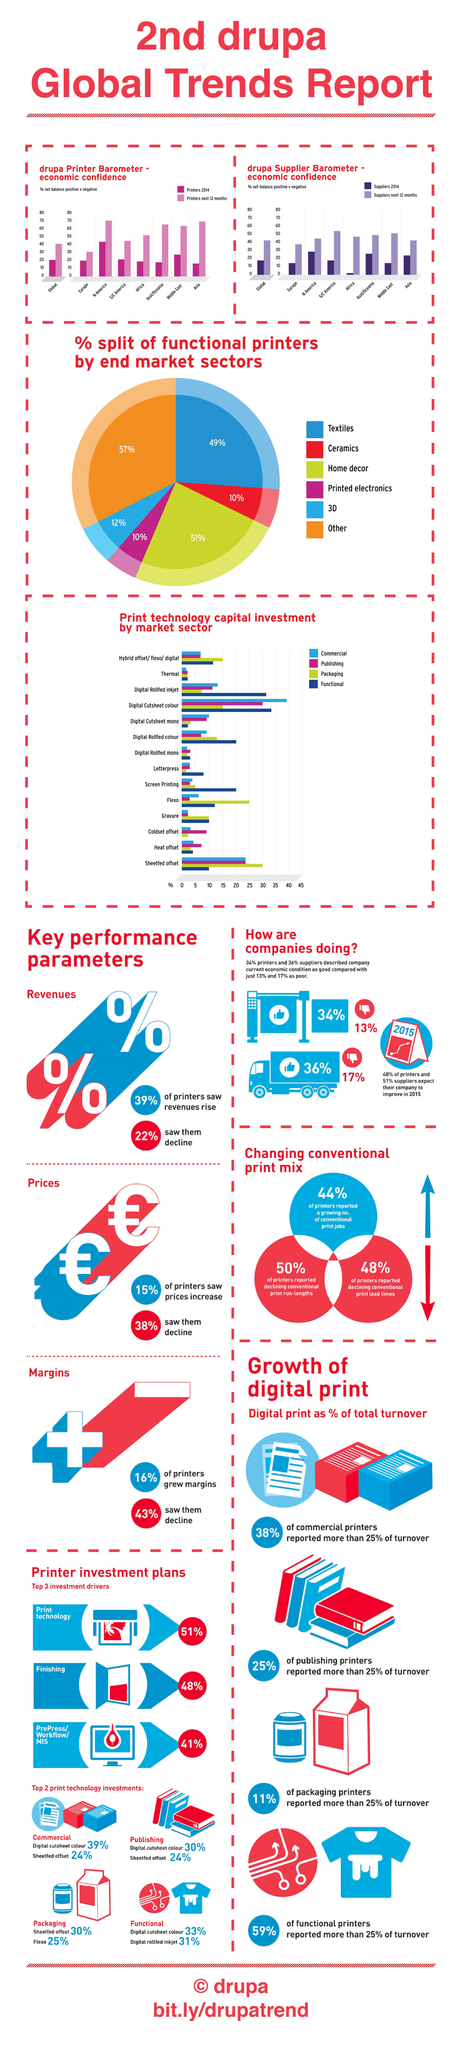Which are the two print technology investments in packaging?
Answer the question with a short phrase. Sheeted Offset, Flexo Which industry has the largest percentage split of functional printers, home decor, textiles, or 3D? home decor Which market sector has the lowest capital investment in functional print technology? Thermal, Digital Cutsheet mono What is the percentage of capital investment for Gravure in packaging and functional print technology? 10% Which market sector has the highest capital investment in commercial print technology? Digital Cutsheet Colour Which market sector has the lowest capital investment in packaging print technology? Letterpress What is the largest market share percentage of fucntional printers? 57% What is the percentage split of functional printers in ceramics and printed electronics? 10% Which market sector has the highest capital investment in publishing print technology? Digital Cutsheet Colour Which are the two print technology investments in publishing? Digital cutsheet colour, Sheetfed offset 